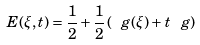<formula> <loc_0><loc_0><loc_500><loc_500>E ( \xi , t ) = \frac { 1 } { 2 } + \frac { 1 } { 2 } \, ( \ g ( \xi ) + t \, \ g )</formula> 